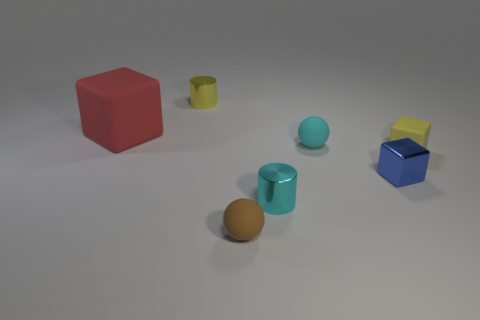Add 1 big purple matte things. How many objects exist? 8 Subtract all blocks. How many objects are left? 4 Add 5 yellow matte things. How many yellow matte things are left? 6 Add 1 brown rubber spheres. How many brown rubber spheres exist? 2 Subtract 0 yellow spheres. How many objects are left? 7 Subtract all cyan spheres. Subtract all rubber cubes. How many objects are left? 4 